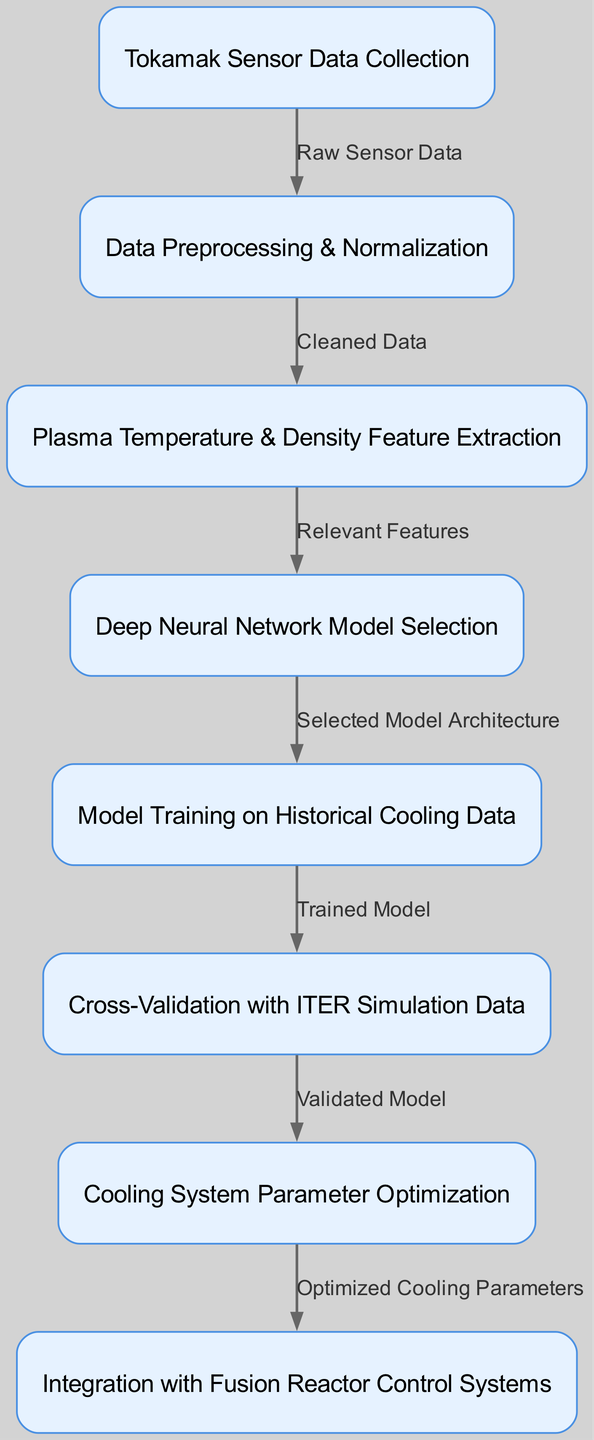What is the first step in the workflow? The first step in the workflow, as represented by the initial node, is "Tokamak Sensor Data Collection". This indicates that the process begins by collecting sensor data from a Tokamak reactor, which is necessary for the subsequent steps.
Answer: Tokamak Sensor Data Collection How many nodes are present in the diagram? By counting the nodes listed in the diagram, we see there are eight distinct nodes: data collection, preprocessing, feature extraction, model selection, training, validation, optimization, and deployment.
Answer: Eight What type of data is processed after "Data Preprocessing & Normalization"? After the "Data Preprocessing & Normalization" node, the next step involves the output of "Cleaned Data", indicating that the data that has been preprocessed is ready for feature extraction.
Answer: Cleaned Data What connects "Model Training on Historical Cooling Data" to "Cross-Validation with ITER Simulation Data"? The connection between "Model Training on Historical Cooling Data" and "Cross-Validation with ITER Simulation Data" is labeled as "Trained Model", indicating that the trained model is the output from the training process that is used for validation.
Answer: Trained Model What outputs the "Optimized Cooling Parameters"? The "Optimized Cooling Parameters" is the output of the "Cooling System Parameter Optimization" step, indicating that once optimization is complete, these parameters will be utilized in the next phase.
Answer: Cooling System Parameter Optimization Which two nodes represent the final steps before integration? The two nodes before integration are "Cooling System Parameter Optimization" and "Integration with Fusion Reactor Control Systems". After optimizing the parameters, integration is the next logical step.
Answer: Cooling System Parameter Optimization and Integration with Fusion Reactor Control Systems What is the relationship between "Deep Neural Network Model Selection" and "Model Training on Historical Cooling Data"? The relationship is defined by the edge labeled "Selected Model Architecture", indicating that the chosen architecture from the model selection process directly influences the training of the model on historical cooling data.
Answer: Selected Model Architecture How does "Plasma Temperature & Density Feature Extraction" impact the workflow? The "Plasma Temperature & Density Feature Extraction" node provides "Relevant Features" to the model selection step, which means that the extraction of relevant plasma characteristics is crucial for determining which model to use.
Answer: Relevant Features 